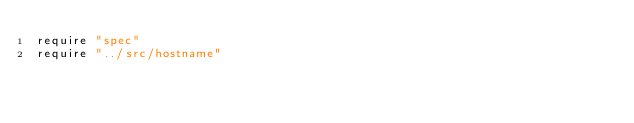<code> <loc_0><loc_0><loc_500><loc_500><_Crystal_>require "spec"
require "../src/hostname"
</code> 